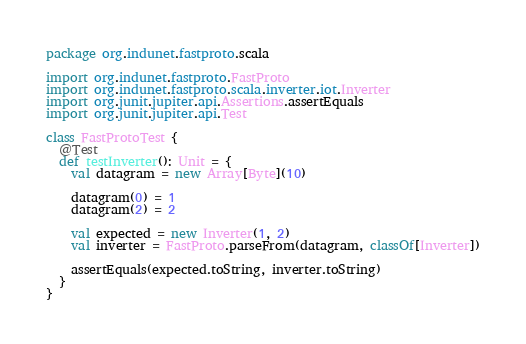Convert code to text. <code><loc_0><loc_0><loc_500><loc_500><_Scala_>package org.indunet.fastproto.scala

import org.indunet.fastproto.FastProto
import org.indunet.fastproto.scala.inverter.iot.Inverter
import org.junit.jupiter.api.Assertions.assertEquals
import org.junit.jupiter.api.Test

class FastProtoTest {
  @Test
  def testInverter(): Unit = {
    val datagram = new Array[Byte](10)

    datagram(0) = 1
    datagram(2) = 2

    val expected = new Inverter(1, 2)
    val inverter = FastProto.parseFrom(datagram, classOf[Inverter])

    assertEquals(expected.toString, inverter.toString)
  }
}
</code> 